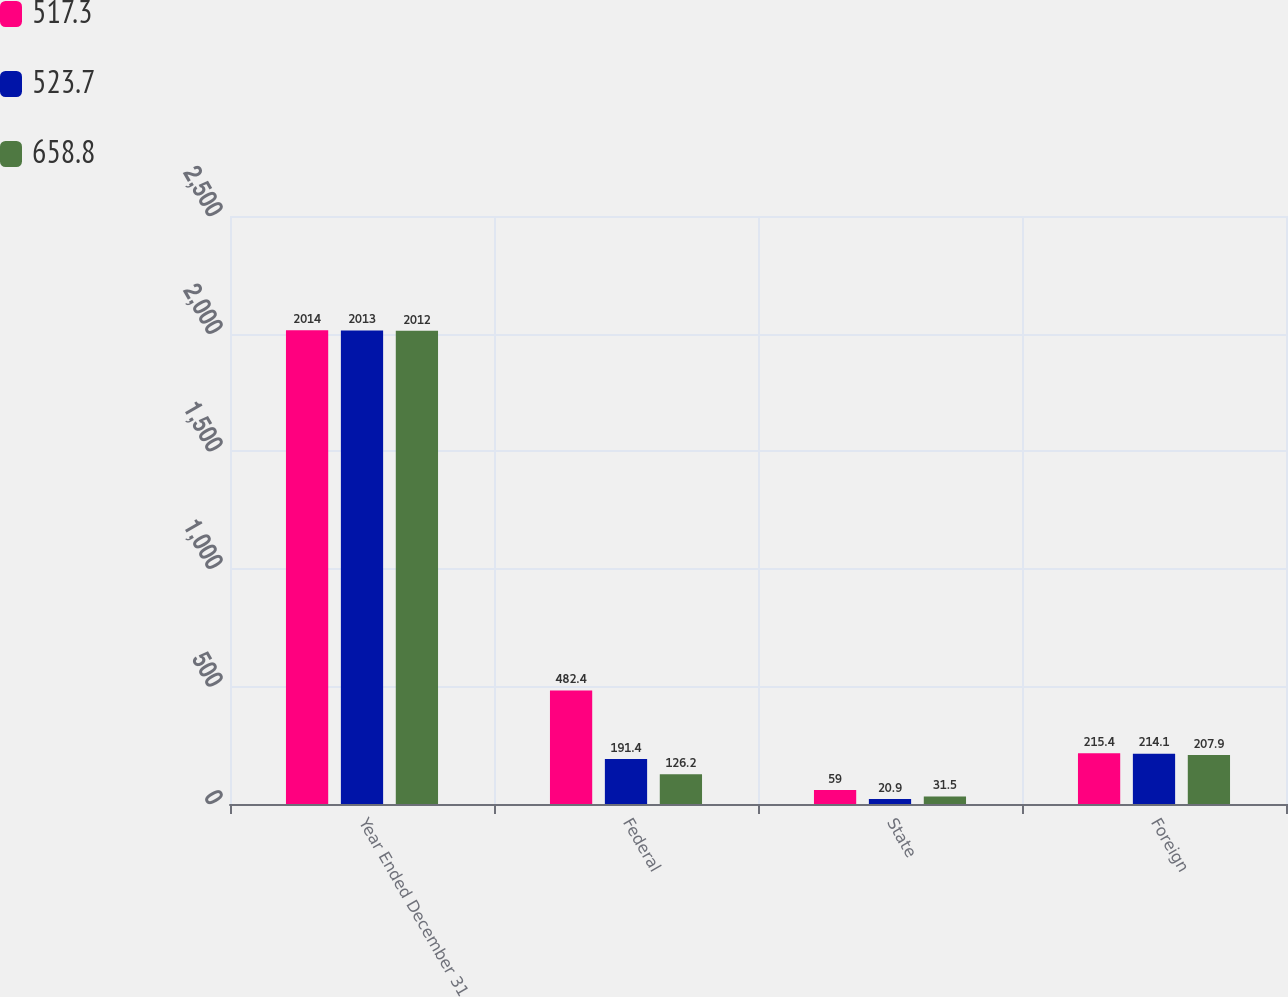<chart> <loc_0><loc_0><loc_500><loc_500><stacked_bar_chart><ecel><fcel>Year Ended December 31<fcel>Federal<fcel>State<fcel>Foreign<nl><fcel>517.3<fcel>2014<fcel>482.4<fcel>59<fcel>215.4<nl><fcel>523.7<fcel>2013<fcel>191.4<fcel>20.9<fcel>214.1<nl><fcel>658.8<fcel>2012<fcel>126.2<fcel>31.5<fcel>207.9<nl></chart> 